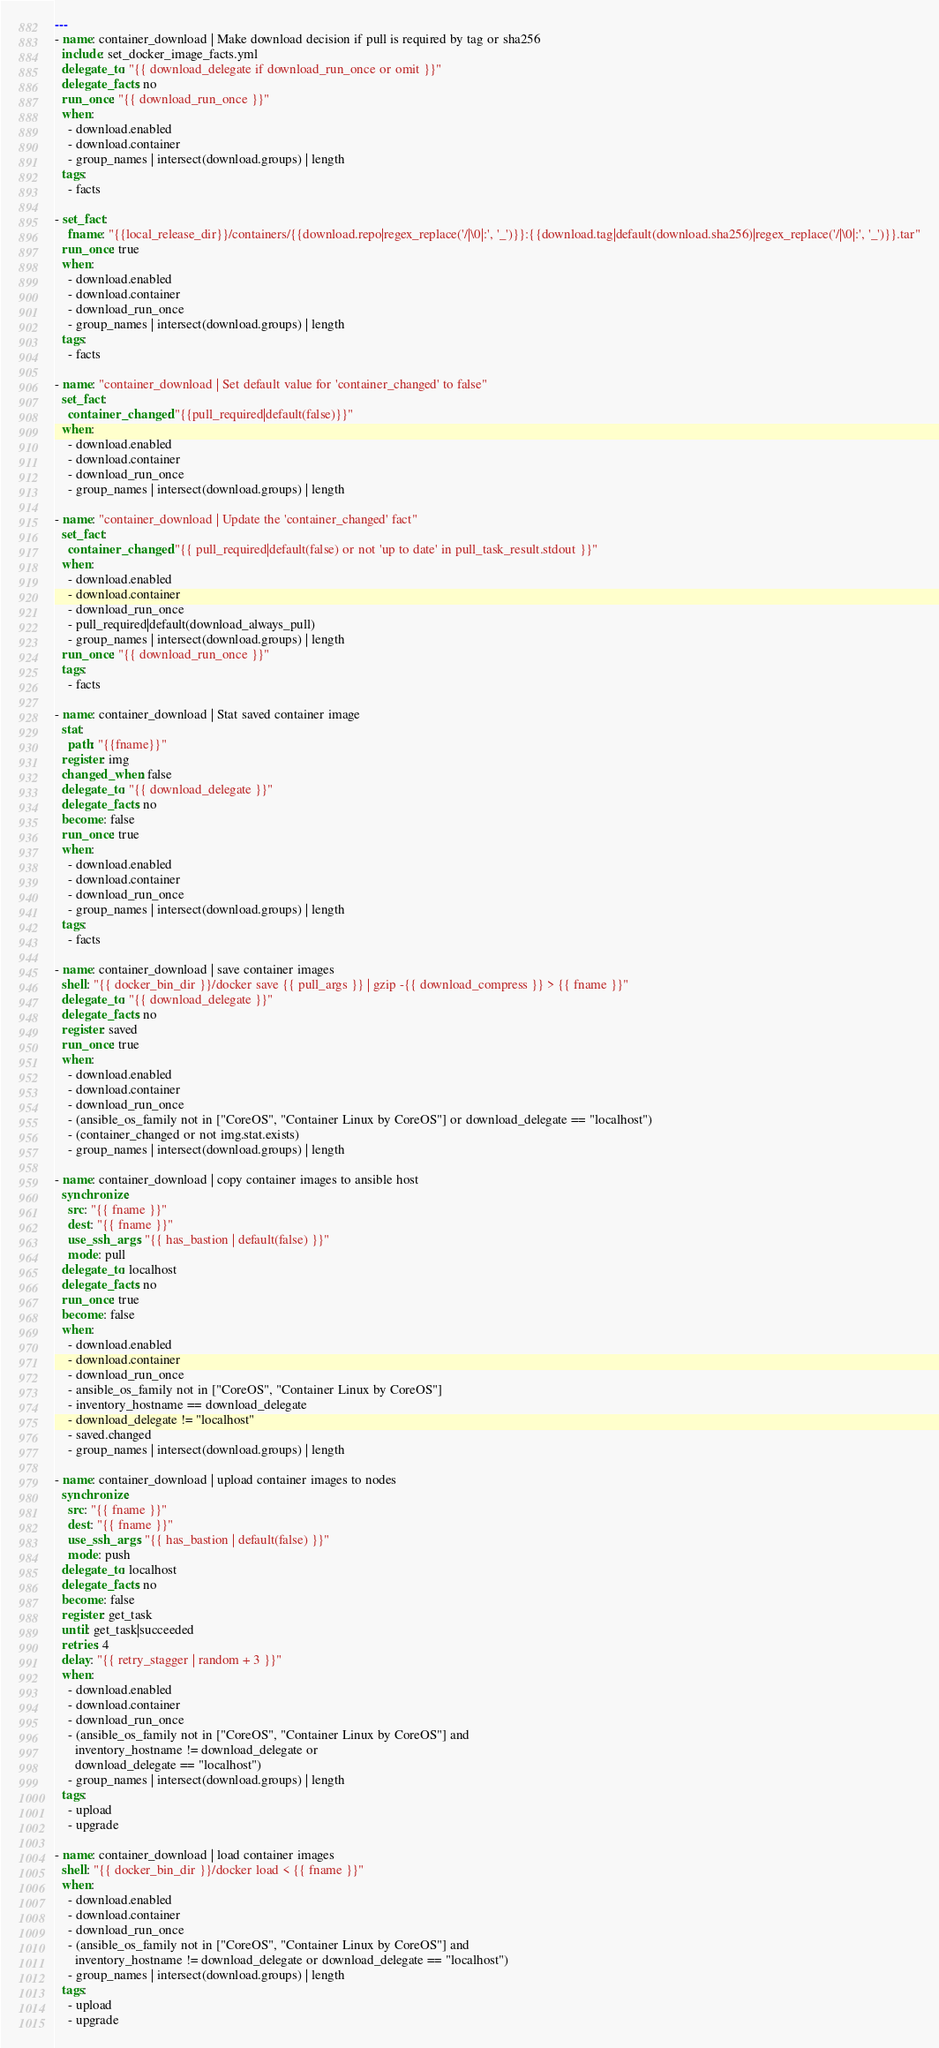Convert code to text. <code><loc_0><loc_0><loc_500><loc_500><_YAML_>---
- name: container_download | Make download decision if pull is required by tag or sha256
  include: set_docker_image_facts.yml
  delegate_to: "{{ download_delegate if download_run_once or omit }}"
  delegate_facts: no
  run_once: "{{ download_run_once }}"
  when:
    - download.enabled
    - download.container
    - group_names | intersect(download.groups) | length
  tags:
    - facts

- set_fact:
    fname: "{{local_release_dir}}/containers/{{download.repo|regex_replace('/|\0|:', '_')}}:{{download.tag|default(download.sha256)|regex_replace('/|\0|:', '_')}}.tar"
  run_once: true
  when:
    - download.enabled
    - download.container
    - download_run_once
    - group_names | intersect(download.groups) | length
  tags:
    - facts

- name: "container_download | Set default value for 'container_changed' to false"
  set_fact:
    container_changed: "{{pull_required|default(false)}}"
  when:
    - download.enabled
    - download.container
    - download_run_once
    - group_names | intersect(download.groups) | length

- name: "container_download | Update the 'container_changed' fact"
  set_fact:
    container_changed: "{{ pull_required|default(false) or not 'up to date' in pull_task_result.stdout }}"
  when:
    - download.enabled
    - download.container
    - download_run_once
    - pull_required|default(download_always_pull)
    - group_names | intersect(download.groups) | length
  run_once: "{{ download_run_once }}"
  tags:
    - facts

- name: container_download | Stat saved container image
  stat:
    path: "{{fname}}"
  register: img
  changed_when: false
  delegate_to: "{{ download_delegate }}"
  delegate_facts: no
  become: false
  run_once: true
  when:
    - download.enabled
    - download.container
    - download_run_once
    - group_names | intersect(download.groups) | length
  tags:
    - facts

- name: container_download | save container images
  shell: "{{ docker_bin_dir }}/docker save {{ pull_args }} | gzip -{{ download_compress }} > {{ fname }}"
  delegate_to: "{{ download_delegate }}"
  delegate_facts: no
  register: saved
  run_once: true
  when:
    - download.enabled
    - download.container
    - download_run_once
    - (ansible_os_family not in ["CoreOS", "Container Linux by CoreOS"] or download_delegate == "localhost")
    - (container_changed or not img.stat.exists)
    - group_names | intersect(download.groups) | length

- name: container_download | copy container images to ansible host
  synchronize:
    src: "{{ fname }}"
    dest: "{{ fname }}"
    use_ssh_args: "{{ has_bastion | default(false) }}"
    mode: pull
  delegate_to: localhost
  delegate_facts: no
  run_once: true
  become: false
  when:
    - download.enabled
    - download.container
    - download_run_once
    - ansible_os_family not in ["CoreOS", "Container Linux by CoreOS"]
    - inventory_hostname == download_delegate
    - download_delegate != "localhost"
    - saved.changed
    - group_names | intersect(download.groups) | length

- name: container_download | upload container images to nodes
  synchronize:
    src: "{{ fname }}"
    dest: "{{ fname }}"
    use_ssh_args: "{{ has_bastion | default(false) }}"
    mode: push
  delegate_to: localhost
  delegate_facts: no
  become: false
  register: get_task
  until: get_task|succeeded
  retries: 4
  delay: "{{ retry_stagger | random + 3 }}"
  when:
    - download.enabled
    - download.container
    - download_run_once
    - (ansible_os_family not in ["CoreOS", "Container Linux by CoreOS"] and
      inventory_hostname != download_delegate or
      download_delegate == "localhost")
    - group_names | intersect(download.groups) | length
  tags:
    - upload
    - upgrade

- name: container_download | load container images
  shell: "{{ docker_bin_dir }}/docker load < {{ fname }}"
  when:
    - download.enabled
    - download.container
    - download_run_once
    - (ansible_os_family not in ["CoreOS", "Container Linux by CoreOS"] and
      inventory_hostname != download_delegate or download_delegate == "localhost")
    - group_names | intersect(download.groups) | length
  tags:
    - upload
    - upgrade
</code> 